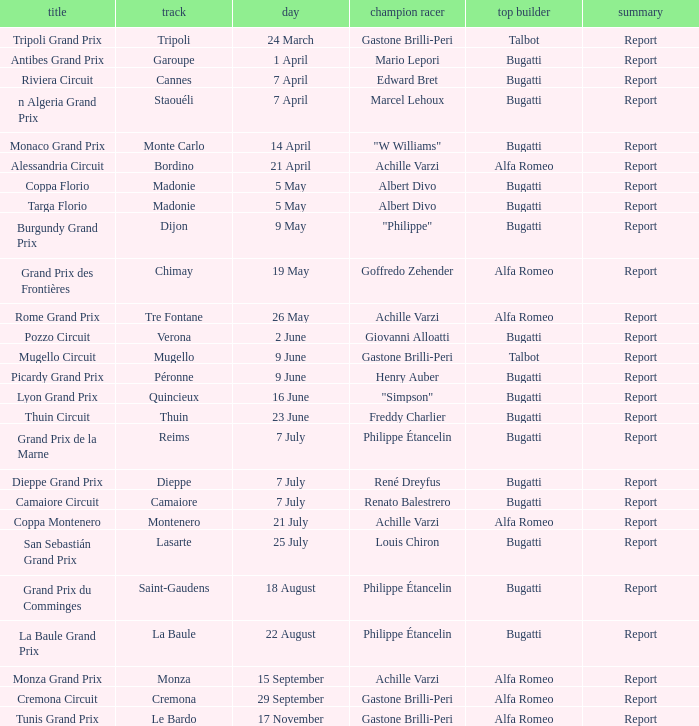What Name has a Winning constructor of bugatti, and a Winning driver of louis chiron? San Sebastián Grand Prix. 